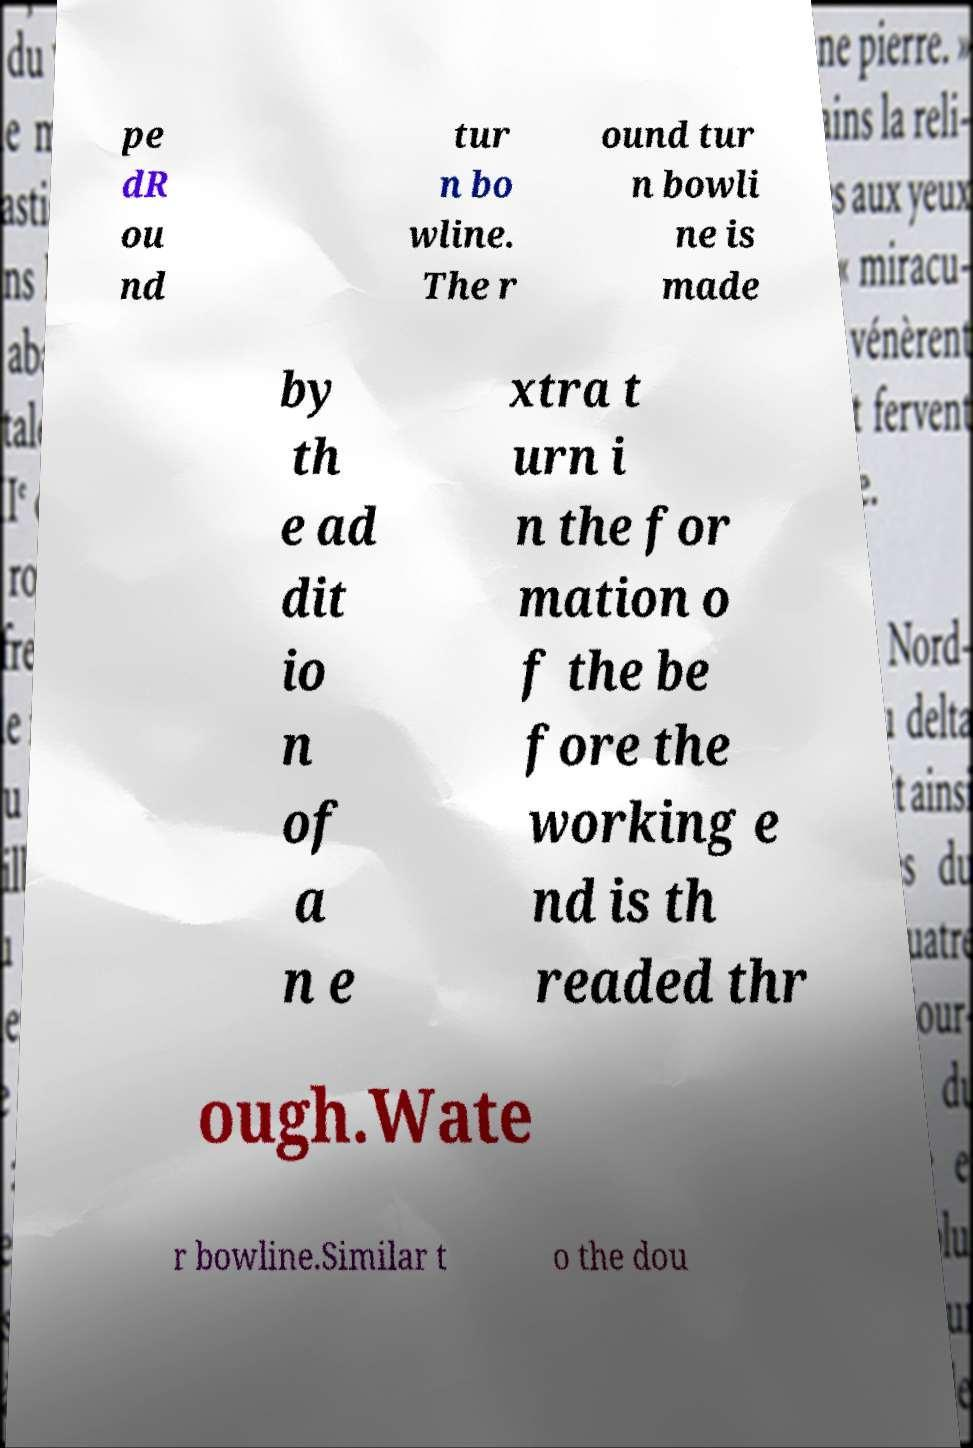There's text embedded in this image that I need extracted. Can you transcribe it verbatim? pe dR ou nd tur n bo wline. The r ound tur n bowli ne is made by th e ad dit io n of a n e xtra t urn i n the for mation o f the be fore the working e nd is th readed thr ough.Wate r bowline.Similar t o the dou 